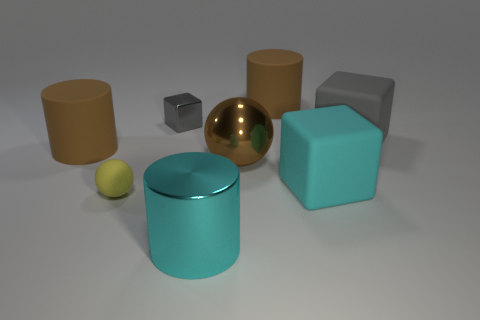What is the shape of the large brown rubber thing on the right side of the metallic object that is behind the rubber cylinder to the left of the tiny gray shiny thing?
Make the answer very short. Cylinder. There is a shiny object behind the brown rubber object on the left side of the small gray shiny thing; what is its shape?
Provide a succinct answer. Cube. Is there a cyan thing made of the same material as the big sphere?
Your response must be concise. Yes. What size is the matte cube that is the same color as the tiny metal cube?
Your answer should be compact. Large. What number of red things are metallic balls or big matte spheres?
Offer a terse response. 0. Are there any other metallic spheres of the same color as the shiny ball?
Give a very brief answer. No. The yellow sphere that is made of the same material as the big cyan block is what size?
Make the answer very short. Small. How many balls are yellow rubber things or big brown rubber objects?
Provide a short and direct response. 1. Are there more tiny gray rubber balls than yellow balls?
Make the answer very short. No. What number of rubber spheres are the same size as the yellow thing?
Your answer should be compact. 0. 